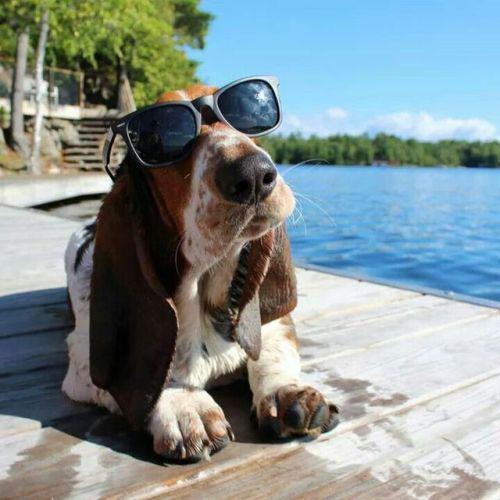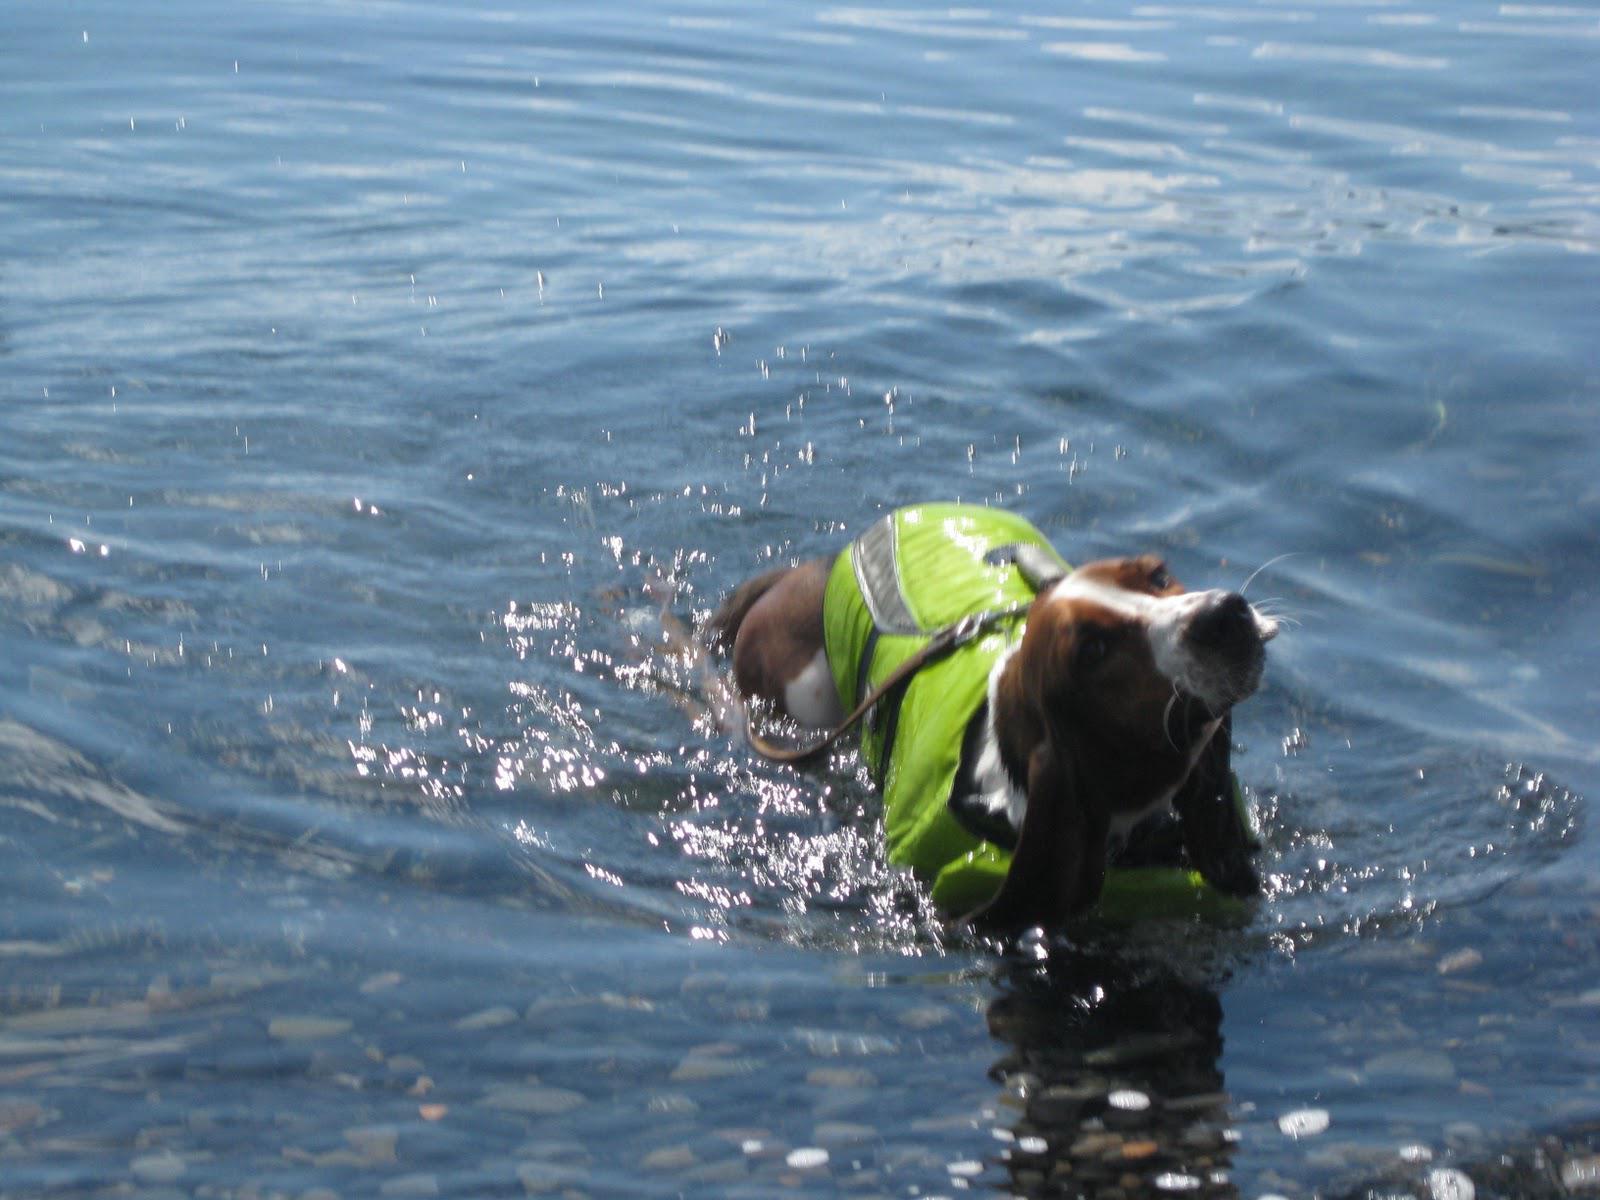The first image is the image on the left, the second image is the image on the right. Assess this claim about the two images: "In one of the images there is a Basset Hound wearing sunglasses.". Correct or not? Answer yes or no. Yes. 